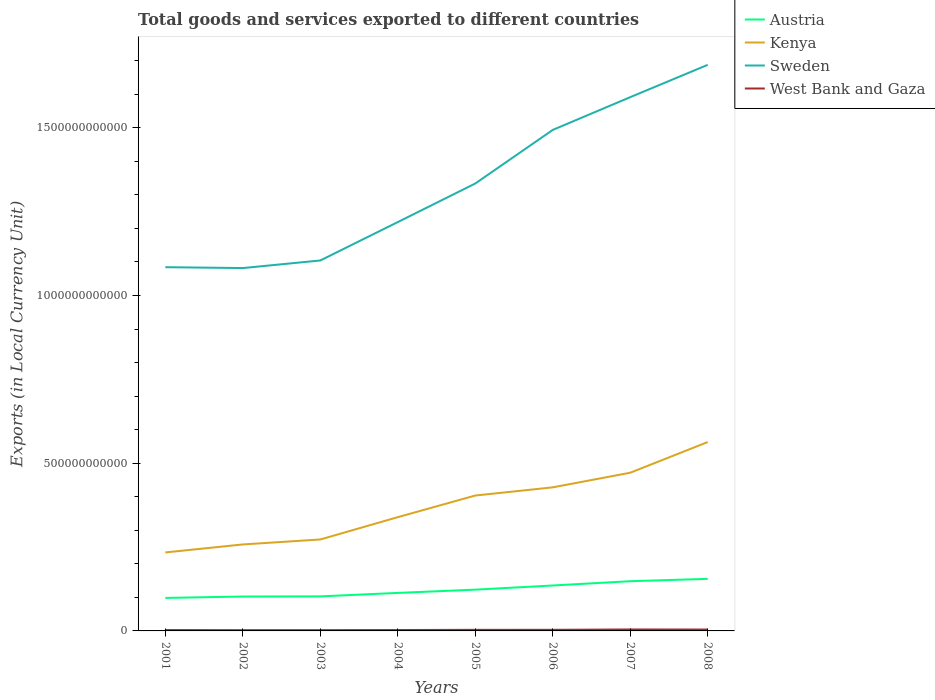How many different coloured lines are there?
Offer a terse response. 4. Does the line corresponding to West Bank and Gaza intersect with the line corresponding to Kenya?
Ensure brevity in your answer.  No. Is the number of lines equal to the number of legend labels?
Keep it short and to the point. Yes. Across all years, what is the maximum Amount of goods and services exports in Austria?
Your answer should be compact. 9.84e+1. What is the total Amount of goods and services exports in West Bank and Gaza in the graph?
Your answer should be very brief. -8.07e+07. What is the difference between the highest and the second highest Amount of goods and services exports in West Bank and Gaza?
Provide a short and direct response. 2.12e+09. Is the Amount of goods and services exports in West Bank and Gaza strictly greater than the Amount of goods and services exports in Sweden over the years?
Keep it short and to the point. Yes. How many years are there in the graph?
Your response must be concise. 8. What is the difference between two consecutive major ticks on the Y-axis?
Your answer should be compact. 5.00e+11. Are the values on the major ticks of Y-axis written in scientific E-notation?
Provide a short and direct response. No. Does the graph contain grids?
Your answer should be compact. No. Where does the legend appear in the graph?
Make the answer very short. Top right. How many legend labels are there?
Provide a succinct answer. 4. What is the title of the graph?
Give a very brief answer. Total goods and services exported to different countries. What is the label or title of the Y-axis?
Ensure brevity in your answer.  Exports (in Local Currency Unit). What is the Exports (in Local Currency Unit) in Austria in 2001?
Provide a succinct answer. 9.84e+1. What is the Exports (in Local Currency Unit) in Kenya in 2001?
Provide a succinct answer. 2.34e+11. What is the Exports (in Local Currency Unit) in Sweden in 2001?
Your response must be concise. 1.08e+12. What is the Exports (in Local Currency Unit) in West Bank and Gaza in 2001?
Give a very brief answer. 2.59e+09. What is the Exports (in Local Currency Unit) in Austria in 2002?
Give a very brief answer. 1.03e+11. What is the Exports (in Local Currency Unit) in Kenya in 2002?
Give a very brief answer. 2.58e+11. What is the Exports (in Local Currency Unit) in Sweden in 2002?
Offer a very short reply. 1.08e+12. What is the Exports (in Local Currency Unit) in West Bank and Gaza in 2002?
Keep it short and to the point. 2.26e+09. What is the Exports (in Local Currency Unit) of Austria in 2003?
Give a very brief answer. 1.03e+11. What is the Exports (in Local Currency Unit) in Kenya in 2003?
Give a very brief answer. 2.73e+11. What is the Exports (in Local Currency Unit) of Sweden in 2003?
Provide a short and direct response. 1.10e+12. What is the Exports (in Local Currency Unit) of West Bank and Gaza in 2003?
Your answer should be very brief. 2.34e+09. What is the Exports (in Local Currency Unit) of Austria in 2004?
Ensure brevity in your answer.  1.13e+11. What is the Exports (in Local Currency Unit) of Kenya in 2004?
Offer a terse response. 3.39e+11. What is the Exports (in Local Currency Unit) of Sweden in 2004?
Your answer should be very brief. 1.22e+12. What is the Exports (in Local Currency Unit) in West Bank and Gaza in 2004?
Make the answer very short. 2.67e+09. What is the Exports (in Local Currency Unit) in Austria in 2005?
Offer a terse response. 1.23e+11. What is the Exports (in Local Currency Unit) of Kenya in 2005?
Your response must be concise. 4.04e+11. What is the Exports (in Local Currency Unit) of Sweden in 2005?
Give a very brief answer. 1.33e+12. What is the Exports (in Local Currency Unit) in West Bank and Gaza in 2005?
Your response must be concise. 3.25e+09. What is the Exports (in Local Currency Unit) in Austria in 2006?
Make the answer very short. 1.35e+11. What is the Exports (in Local Currency Unit) of Kenya in 2006?
Your response must be concise. 4.28e+11. What is the Exports (in Local Currency Unit) in Sweden in 2006?
Provide a succinct answer. 1.49e+12. What is the Exports (in Local Currency Unit) in West Bank and Gaza in 2006?
Keep it short and to the point. 3.28e+09. What is the Exports (in Local Currency Unit) in Austria in 2007?
Offer a terse response. 1.48e+11. What is the Exports (in Local Currency Unit) of Kenya in 2007?
Offer a very short reply. 4.72e+11. What is the Exports (in Local Currency Unit) of Sweden in 2007?
Your answer should be very brief. 1.59e+12. What is the Exports (in Local Currency Unit) of West Bank and Gaza in 2007?
Offer a terse response. 4.38e+09. What is the Exports (in Local Currency Unit) of Austria in 2008?
Provide a short and direct response. 1.55e+11. What is the Exports (in Local Currency Unit) of Kenya in 2008?
Keep it short and to the point. 5.63e+11. What is the Exports (in Local Currency Unit) in Sweden in 2008?
Provide a short and direct response. 1.69e+12. What is the Exports (in Local Currency Unit) of West Bank and Gaza in 2008?
Provide a succinct answer. 4.12e+09. Across all years, what is the maximum Exports (in Local Currency Unit) in Austria?
Offer a terse response. 1.55e+11. Across all years, what is the maximum Exports (in Local Currency Unit) in Kenya?
Your answer should be compact. 5.63e+11. Across all years, what is the maximum Exports (in Local Currency Unit) of Sweden?
Offer a very short reply. 1.69e+12. Across all years, what is the maximum Exports (in Local Currency Unit) of West Bank and Gaza?
Offer a terse response. 4.38e+09. Across all years, what is the minimum Exports (in Local Currency Unit) of Austria?
Provide a short and direct response. 9.84e+1. Across all years, what is the minimum Exports (in Local Currency Unit) in Kenya?
Make the answer very short. 2.34e+11. Across all years, what is the minimum Exports (in Local Currency Unit) in Sweden?
Your answer should be very brief. 1.08e+12. Across all years, what is the minimum Exports (in Local Currency Unit) in West Bank and Gaza?
Ensure brevity in your answer.  2.26e+09. What is the total Exports (in Local Currency Unit) of Austria in the graph?
Make the answer very short. 9.79e+11. What is the total Exports (in Local Currency Unit) in Kenya in the graph?
Your response must be concise. 2.97e+12. What is the total Exports (in Local Currency Unit) in Sweden in the graph?
Ensure brevity in your answer.  1.06e+13. What is the total Exports (in Local Currency Unit) in West Bank and Gaza in the graph?
Keep it short and to the point. 2.49e+1. What is the difference between the Exports (in Local Currency Unit) in Austria in 2001 and that in 2002?
Your answer should be compact. -4.17e+09. What is the difference between the Exports (in Local Currency Unit) of Kenya in 2001 and that in 2002?
Give a very brief answer. -2.38e+1. What is the difference between the Exports (in Local Currency Unit) of Sweden in 2001 and that in 2002?
Your answer should be compact. 2.62e+09. What is the difference between the Exports (in Local Currency Unit) of West Bank and Gaza in 2001 and that in 2002?
Provide a succinct answer. 3.28e+08. What is the difference between the Exports (in Local Currency Unit) of Austria in 2001 and that in 2003?
Offer a very short reply. -4.61e+09. What is the difference between the Exports (in Local Currency Unit) in Kenya in 2001 and that in 2003?
Keep it short and to the point. -3.87e+1. What is the difference between the Exports (in Local Currency Unit) in Sweden in 2001 and that in 2003?
Give a very brief answer. -2.00e+1. What is the difference between the Exports (in Local Currency Unit) in West Bank and Gaza in 2001 and that in 2003?
Give a very brief answer. 2.54e+08. What is the difference between the Exports (in Local Currency Unit) of Austria in 2001 and that in 2004?
Your response must be concise. -1.49e+1. What is the difference between the Exports (in Local Currency Unit) in Kenya in 2001 and that in 2004?
Provide a short and direct response. -1.05e+11. What is the difference between the Exports (in Local Currency Unit) in Sweden in 2001 and that in 2004?
Your answer should be very brief. -1.34e+11. What is the difference between the Exports (in Local Currency Unit) in West Bank and Gaza in 2001 and that in 2004?
Your answer should be compact. -8.07e+07. What is the difference between the Exports (in Local Currency Unit) of Austria in 2001 and that in 2005?
Provide a succinct answer. -2.47e+1. What is the difference between the Exports (in Local Currency Unit) of Kenya in 2001 and that in 2005?
Your answer should be compact. -1.70e+11. What is the difference between the Exports (in Local Currency Unit) of Sweden in 2001 and that in 2005?
Make the answer very short. -2.49e+11. What is the difference between the Exports (in Local Currency Unit) in West Bank and Gaza in 2001 and that in 2005?
Keep it short and to the point. -6.55e+08. What is the difference between the Exports (in Local Currency Unit) of Austria in 2001 and that in 2006?
Your response must be concise. -3.71e+1. What is the difference between the Exports (in Local Currency Unit) of Kenya in 2001 and that in 2006?
Keep it short and to the point. -1.94e+11. What is the difference between the Exports (in Local Currency Unit) of Sweden in 2001 and that in 2006?
Offer a terse response. -4.09e+11. What is the difference between the Exports (in Local Currency Unit) in West Bank and Gaza in 2001 and that in 2006?
Your answer should be compact. -6.91e+08. What is the difference between the Exports (in Local Currency Unit) of Austria in 2001 and that in 2007?
Offer a terse response. -4.98e+1. What is the difference between the Exports (in Local Currency Unit) of Kenya in 2001 and that in 2007?
Your response must be concise. -2.38e+11. What is the difference between the Exports (in Local Currency Unit) in Sweden in 2001 and that in 2007?
Offer a very short reply. -5.07e+11. What is the difference between the Exports (in Local Currency Unit) in West Bank and Gaza in 2001 and that in 2007?
Offer a very short reply. -1.79e+09. What is the difference between the Exports (in Local Currency Unit) of Austria in 2001 and that in 2008?
Your answer should be very brief. -5.68e+1. What is the difference between the Exports (in Local Currency Unit) in Kenya in 2001 and that in 2008?
Your response must be concise. -3.29e+11. What is the difference between the Exports (in Local Currency Unit) of Sweden in 2001 and that in 2008?
Provide a short and direct response. -6.03e+11. What is the difference between the Exports (in Local Currency Unit) of West Bank and Gaza in 2001 and that in 2008?
Offer a very short reply. -1.53e+09. What is the difference between the Exports (in Local Currency Unit) in Austria in 2002 and that in 2003?
Your response must be concise. -4.44e+08. What is the difference between the Exports (in Local Currency Unit) in Kenya in 2002 and that in 2003?
Make the answer very short. -1.48e+1. What is the difference between the Exports (in Local Currency Unit) of Sweden in 2002 and that in 2003?
Your answer should be very brief. -2.26e+1. What is the difference between the Exports (in Local Currency Unit) of West Bank and Gaza in 2002 and that in 2003?
Ensure brevity in your answer.  -7.38e+07. What is the difference between the Exports (in Local Currency Unit) of Austria in 2002 and that in 2004?
Ensure brevity in your answer.  -1.08e+1. What is the difference between the Exports (in Local Currency Unit) of Kenya in 2002 and that in 2004?
Your answer should be compact. -8.13e+1. What is the difference between the Exports (in Local Currency Unit) in Sweden in 2002 and that in 2004?
Ensure brevity in your answer.  -1.37e+11. What is the difference between the Exports (in Local Currency Unit) in West Bank and Gaza in 2002 and that in 2004?
Your answer should be very brief. -4.09e+08. What is the difference between the Exports (in Local Currency Unit) in Austria in 2002 and that in 2005?
Offer a terse response. -2.05e+1. What is the difference between the Exports (in Local Currency Unit) of Kenya in 2002 and that in 2005?
Provide a succinct answer. -1.46e+11. What is the difference between the Exports (in Local Currency Unit) in Sweden in 2002 and that in 2005?
Make the answer very short. -2.52e+11. What is the difference between the Exports (in Local Currency Unit) in West Bank and Gaza in 2002 and that in 2005?
Ensure brevity in your answer.  -9.83e+08. What is the difference between the Exports (in Local Currency Unit) in Austria in 2002 and that in 2006?
Your answer should be compact. -3.29e+1. What is the difference between the Exports (in Local Currency Unit) in Kenya in 2002 and that in 2006?
Your answer should be very brief. -1.70e+11. What is the difference between the Exports (in Local Currency Unit) of Sweden in 2002 and that in 2006?
Your answer should be compact. -4.12e+11. What is the difference between the Exports (in Local Currency Unit) in West Bank and Gaza in 2002 and that in 2006?
Your answer should be compact. -1.02e+09. What is the difference between the Exports (in Local Currency Unit) of Austria in 2002 and that in 2007?
Offer a very short reply. -4.57e+1. What is the difference between the Exports (in Local Currency Unit) in Kenya in 2002 and that in 2007?
Give a very brief answer. -2.14e+11. What is the difference between the Exports (in Local Currency Unit) of Sweden in 2002 and that in 2007?
Give a very brief answer. -5.09e+11. What is the difference between the Exports (in Local Currency Unit) in West Bank and Gaza in 2002 and that in 2007?
Provide a short and direct response. -2.12e+09. What is the difference between the Exports (in Local Currency Unit) in Austria in 2002 and that in 2008?
Your answer should be very brief. -5.26e+1. What is the difference between the Exports (in Local Currency Unit) of Kenya in 2002 and that in 2008?
Your answer should be very brief. -3.05e+11. What is the difference between the Exports (in Local Currency Unit) of Sweden in 2002 and that in 2008?
Keep it short and to the point. -6.06e+11. What is the difference between the Exports (in Local Currency Unit) of West Bank and Gaza in 2002 and that in 2008?
Your answer should be very brief. -1.86e+09. What is the difference between the Exports (in Local Currency Unit) in Austria in 2003 and that in 2004?
Your answer should be compact. -1.03e+1. What is the difference between the Exports (in Local Currency Unit) of Kenya in 2003 and that in 2004?
Provide a short and direct response. -6.65e+1. What is the difference between the Exports (in Local Currency Unit) in Sweden in 2003 and that in 2004?
Provide a succinct answer. -1.14e+11. What is the difference between the Exports (in Local Currency Unit) in West Bank and Gaza in 2003 and that in 2004?
Give a very brief answer. -3.35e+08. What is the difference between the Exports (in Local Currency Unit) of Austria in 2003 and that in 2005?
Make the answer very short. -2.01e+1. What is the difference between the Exports (in Local Currency Unit) in Kenya in 2003 and that in 2005?
Make the answer very short. -1.31e+11. What is the difference between the Exports (in Local Currency Unit) in Sweden in 2003 and that in 2005?
Your answer should be very brief. -2.29e+11. What is the difference between the Exports (in Local Currency Unit) in West Bank and Gaza in 2003 and that in 2005?
Your answer should be very brief. -9.09e+08. What is the difference between the Exports (in Local Currency Unit) in Austria in 2003 and that in 2006?
Make the answer very short. -3.25e+1. What is the difference between the Exports (in Local Currency Unit) in Kenya in 2003 and that in 2006?
Keep it short and to the point. -1.55e+11. What is the difference between the Exports (in Local Currency Unit) of Sweden in 2003 and that in 2006?
Keep it short and to the point. -3.89e+11. What is the difference between the Exports (in Local Currency Unit) of West Bank and Gaza in 2003 and that in 2006?
Provide a short and direct response. -9.45e+08. What is the difference between the Exports (in Local Currency Unit) in Austria in 2003 and that in 2007?
Offer a very short reply. -4.52e+1. What is the difference between the Exports (in Local Currency Unit) in Kenya in 2003 and that in 2007?
Provide a short and direct response. -1.99e+11. What is the difference between the Exports (in Local Currency Unit) of Sweden in 2003 and that in 2007?
Offer a very short reply. -4.87e+11. What is the difference between the Exports (in Local Currency Unit) in West Bank and Gaza in 2003 and that in 2007?
Your response must be concise. -2.04e+09. What is the difference between the Exports (in Local Currency Unit) in Austria in 2003 and that in 2008?
Provide a succinct answer. -5.22e+1. What is the difference between the Exports (in Local Currency Unit) in Kenya in 2003 and that in 2008?
Offer a terse response. -2.90e+11. What is the difference between the Exports (in Local Currency Unit) in Sweden in 2003 and that in 2008?
Give a very brief answer. -5.83e+11. What is the difference between the Exports (in Local Currency Unit) in West Bank and Gaza in 2003 and that in 2008?
Your answer should be very brief. -1.79e+09. What is the difference between the Exports (in Local Currency Unit) of Austria in 2004 and that in 2005?
Your response must be concise. -9.74e+09. What is the difference between the Exports (in Local Currency Unit) of Kenya in 2004 and that in 2005?
Your answer should be compact. -6.45e+1. What is the difference between the Exports (in Local Currency Unit) of Sweden in 2004 and that in 2005?
Make the answer very short. -1.15e+11. What is the difference between the Exports (in Local Currency Unit) of West Bank and Gaza in 2004 and that in 2005?
Your response must be concise. -5.74e+08. What is the difference between the Exports (in Local Currency Unit) of Austria in 2004 and that in 2006?
Make the answer very short. -2.21e+1. What is the difference between the Exports (in Local Currency Unit) of Kenya in 2004 and that in 2006?
Make the answer very short. -8.89e+1. What is the difference between the Exports (in Local Currency Unit) of Sweden in 2004 and that in 2006?
Your answer should be compact. -2.75e+11. What is the difference between the Exports (in Local Currency Unit) in West Bank and Gaza in 2004 and that in 2006?
Provide a succinct answer. -6.10e+08. What is the difference between the Exports (in Local Currency Unit) of Austria in 2004 and that in 2007?
Keep it short and to the point. -3.49e+1. What is the difference between the Exports (in Local Currency Unit) in Kenya in 2004 and that in 2007?
Provide a short and direct response. -1.32e+11. What is the difference between the Exports (in Local Currency Unit) in Sweden in 2004 and that in 2007?
Provide a short and direct response. -3.72e+11. What is the difference between the Exports (in Local Currency Unit) in West Bank and Gaza in 2004 and that in 2007?
Your answer should be very brief. -1.71e+09. What is the difference between the Exports (in Local Currency Unit) in Austria in 2004 and that in 2008?
Give a very brief answer. -4.19e+1. What is the difference between the Exports (in Local Currency Unit) of Kenya in 2004 and that in 2008?
Make the answer very short. -2.24e+11. What is the difference between the Exports (in Local Currency Unit) in Sweden in 2004 and that in 2008?
Make the answer very short. -4.69e+11. What is the difference between the Exports (in Local Currency Unit) in West Bank and Gaza in 2004 and that in 2008?
Make the answer very short. -1.45e+09. What is the difference between the Exports (in Local Currency Unit) in Austria in 2005 and that in 2006?
Your response must be concise. -1.24e+1. What is the difference between the Exports (in Local Currency Unit) in Kenya in 2005 and that in 2006?
Offer a terse response. -2.44e+1. What is the difference between the Exports (in Local Currency Unit) of Sweden in 2005 and that in 2006?
Give a very brief answer. -1.60e+11. What is the difference between the Exports (in Local Currency Unit) in West Bank and Gaza in 2005 and that in 2006?
Your response must be concise. -3.63e+07. What is the difference between the Exports (in Local Currency Unit) of Austria in 2005 and that in 2007?
Your answer should be very brief. -2.51e+1. What is the difference between the Exports (in Local Currency Unit) in Kenya in 2005 and that in 2007?
Keep it short and to the point. -6.79e+1. What is the difference between the Exports (in Local Currency Unit) in Sweden in 2005 and that in 2007?
Make the answer very short. -2.57e+11. What is the difference between the Exports (in Local Currency Unit) of West Bank and Gaza in 2005 and that in 2007?
Your answer should be very brief. -1.13e+09. What is the difference between the Exports (in Local Currency Unit) in Austria in 2005 and that in 2008?
Your answer should be compact. -3.21e+1. What is the difference between the Exports (in Local Currency Unit) in Kenya in 2005 and that in 2008?
Ensure brevity in your answer.  -1.59e+11. What is the difference between the Exports (in Local Currency Unit) of Sweden in 2005 and that in 2008?
Provide a succinct answer. -3.54e+11. What is the difference between the Exports (in Local Currency Unit) of West Bank and Gaza in 2005 and that in 2008?
Offer a terse response. -8.76e+08. What is the difference between the Exports (in Local Currency Unit) of Austria in 2006 and that in 2007?
Your answer should be very brief. -1.27e+1. What is the difference between the Exports (in Local Currency Unit) of Kenya in 2006 and that in 2007?
Your response must be concise. -4.36e+1. What is the difference between the Exports (in Local Currency Unit) in Sweden in 2006 and that in 2007?
Your answer should be compact. -9.76e+1. What is the difference between the Exports (in Local Currency Unit) of West Bank and Gaza in 2006 and that in 2007?
Your answer should be very brief. -1.10e+09. What is the difference between the Exports (in Local Currency Unit) in Austria in 2006 and that in 2008?
Keep it short and to the point. -1.97e+1. What is the difference between the Exports (in Local Currency Unit) in Kenya in 2006 and that in 2008?
Ensure brevity in your answer.  -1.35e+11. What is the difference between the Exports (in Local Currency Unit) in Sweden in 2006 and that in 2008?
Your response must be concise. -1.94e+11. What is the difference between the Exports (in Local Currency Unit) in West Bank and Gaza in 2006 and that in 2008?
Provide a succinct answer. -8.40e+08. What is the difference between the Exports (in Local Currency Unit) of Austria in 2007 and that in 2008?
Your answer should be very brief. -6.99e+09. What is the difference between the Exports (in Local Currency Unit) in Kenya in 2007 and that in 2008?
Your answer should be compact. -9.15e+1. What is the difference between the Exports (in Local Currency Unit) of Sweden in 2007 and that in 2008?
Give a very brief answer. -9.64e+1. What is the difference between the Exports (in Local Currency Unit) of West Bank and Gaza in 2007 and that in 2008?
Your response must be concise. 2.58e+08. What is the difference between the Exports (in Local Currency Unit) of Austria in 2001 and the Exports (in Local Currency Unit) of Kenya in 2002?
Keep it short and to the point. -1.59e+11. What is the difference between the Exports (in Local Currency Unit) of Austria in 2001 and the Exports (in Local Currency Unit) of Sweden in 2002?
Give a very brief answer. -9.83e+11. What is the difference between the Exports (in Local Currency Unit) in Austria in 2001 and the Exports (in Local Currency Unit) in West Bank and Gaza in 2002?
Your answer should be compact. 9.61e+1. What is the difference between the Exports (in Local Currency Unit) of Kenya in 2001 and the Exports (in Local Currency Unit) of Sweden in 2002?
Offer a terse response. -8.48e+11. What is the difference between the Exports (in Local Currency Unit) in Kenya in 2001 and the Exports (in Local Currency Unit) in West Bank and Gaza in 2002?
Offer a terse response. 2.32e+11. What is the difference between the Exports (in Local Currency Unit) in Sweden in 2001 and the Exports (in Local Currency Unit) in West Bank and Gaza in 2002?
Your response must be concise. 1.08e+12. What is the difference between the Exports (in Local Currency Unit) of Austria in 2001 and the Exports (in Local Currency Unit) of Kenya in 2003?
Your answer should be very brief. -1.74e+11. What is the difference between the Exports (in Local Currency Unit) in Austria in 2001 and the Exports (in Local Currency Unit) in Sweden in 2003?
Give a very brief answer. -1.01e+12. What is the difference between the Exports (in Local Currency Unit) in Austria in 2001 and the Exports (in Local Currency Unit) in West Bank and Gaza in 2003?
Your answer should be compact. 9.60e+1. What is the difference between the Exports (in Local Currency Unit) of Kenya in 2001 and the Exports (in Local Currency Unit) of Sweden in 2003?
Your answer should be very brief. -8.70e+11. What is the difference between the Exports (in Local Currency Unit) of Kenya in 2001 and the Exports (in Local Currency Unit) of West Bank and Gaza in 2003?
Keep it short and to the point. 2.32e+11. What is the difference between the Exports (in Local Currency Unit) in Sweden in 2001 and the Exports (in Local Currency Unit) in West Bank and Gaza in 2003?
Ensure brevity in your answer.  1.08e+12. What is the difference between the Exports (in Local Currency Unit) in Austria in 2001 and the Exports (in Local Currency Unit) in Kenya in 2004?
Your answer should be compact. -2.41e+11. What is the difference between the Exports (in Local Currency Unit) of Austria in 2001 and the Exports (in Local Currency Unit) of Sweden in 2004?
Keep it short and to the point. -1.12e+12. What is the difference between the Exports (in Local Currency Unit) of Austria in 2001 and the Exports (in Local Currency Unit) of West Bank and Gaza in 2004?
Make the answer very short. 9.57e+1. What is the difference between the Exports (in Local Currency Unit) of Kenya in 2001 and the Exports (in Local Currency Unit) of Sweden in 2004?
Ensure brevity in your answer.  -9.85e+11. What is the difference between the Exports (in Local Currency Unit) in Kenya in 2001 and the Exports (in Local Currency Unit) in West Bank and Gaza in 2004?
Your response must be concise. 2.31e+11. What is the difference between the Exports (in Local Currency Unit) of Sweden in 2001 and the Exports (in Local Currency Unit) of West Bank and Gaza in 2004?
Keep it short and to the point. 1.08e+12. What is the difference between the Exports (in Local Currency Unit) of Austria in 2001 and the Exports (in Local Currency Unit) of Kenya in 2005?
Ensure brevity in your answer.  -3.05e+11. What is the difference between the Exports (in Local Currency Unit) in Austria in 2001 and the Exports (in Local Currency Unit) in Sweden in 2005?
Ensure brevity in your answer.  -1.24e+12. What is the difference between the Exports (in Local Currency Unit) in Austria in 2001 and the Exports (in Local Currency Unit) in West Bank and Gaza in 2005?
Keep it short and to the point. 9.51e+1. What is the difference between the Exports (in Local Currency Unit) of Kenya in 2001 and the Exports (in Local Currency Unit) of Sweden in 2005?
Offer a very short reply. -1.10e+12. What is the difference between the Exports (in Local Currency Unit) in Kenya in 2001 and the Exports (in Local Currency Unit) in West Bank and Gaza in 2005?
Keep it short and to the point. 2.31e+11. What is the difference between the Exports (in Local Currency Unit) of Sweden in 2001 and the Exports (in Local Currency Unit) of West Bank and Gaza in 2005?
Provide a short and direct response. 1.08e+12. What is the difference between the Exports (in Local Currency Unit) in Austria in 2001 and the Exports (in Local Currency Unit) in Kenya in 2006?
Give a very brief answer. -3.30e+11. What is the difference between the Exports (in Local Currency Unit) of Austria in 2001 and the Exports (in Local Currency Unit) of Sweden in 2006?
Your answer should be very brief. -1.40e+12. What is the difference between the Exports (in Local Currency Unit) of Austria in 2001 and the Exports (in Local Currency Unit) of West Bank and Gaza in 2006?
Make the answer very short. 9.51e+1. What is the difference between the Exports (in Local Currency Unit) in Kenya in 2001 and the Exports (in Local Currency Unit) in Sweden in 2006?
Make the answer very short. -1.26e+12. What is the difference between the Exports (in Local Currency Unit) in Kenya in 2001 and the Exports (in Local Currency Unit) in West Bank and Gaza in 2006?
Your answer should be compact. 2.31e+11. What is the difference between the Exports (in Local Currency Unit) in Sweden in 2001 and the Exports (in Local Currency Unit) in West Bank and Gaza in 2006?
Offer a very short reply. 1.08e+12. What is the difference between the Exports (in Local Currency Unit) in Austria in 2001 and the Exports (in Local Currency Unit) in Kenya in 2007?
Make the answer very short. -3.73e+11. What is the difference between the Exports (in Local Currency Unit) in Austria in 2001 and the Exports (in Local Currency Unit) in Sweden in 2007?
Offer a terse response. -1.49e+12. What is the difference between the Exports (in Local Currency Unit) of Austria in 2001 and the Exports (in Local Currency Unit) of West Bank and Gaza in 2007?
Provide a short and direct response. 9.40e+1. What is the difference between the Exports (in Local Currency Unit) in Kenya in 2001 and the Exports (in Local Currency Unit) in Sweden in 2007?
Your answer should be compact. -1.36e+12. What is the difference between the Exports (in Local Currency Unit) in Kenya in 2001 and the Exports (in Local Currency Unit) in West Bank and Gaza in 2007?
Give a very brief answer. 2.30e+11. What is the difference between the Exports (in Local Currency Unit) in Sweden in 2001 and the Exports (in Local Currency Unit) in West Bank and Gaza in 2007?
Offer a very short reply. 1.08e+12. What is the difference between the Exports (in Local Currency Unit) of Austria in 2001 and the Exports (in Local Currency Unit) of Kenya in 2008?
Offer a very short reply. -4.65e+11. What is the difference between the Exports (in Local Currency Unit) of Austria in 2001 and the Exports (in Local Currency Unit) of Sweden in 2008?
Your answer should be very brief. -1.59e+12. What is the difference between the Exports (in Local Currency Unit) of Austria in 2001 and the Exports (in Local Currency Unit) of West Bank and Gaza in 2008?
Make the answer very short. 9.42e+1. What is the difference between the Exports (in Local Currency Unit) in Kenya in 2001 and the Exports (in Local Currency Unit) in Sweden in 2008?
Your answer should be very brief. -1.45e+12. What is the difference between the Exports (in Local Currency Unit) in Kenya in 2001 and the Exports (in Local Currency Unit) in West Bank and Gaza in 2008?
Ensure brevity in your answer.  2.30e+11. What is the difference between the Exports (in Local Currency Unit) of Sweden in 2001 and the Exports (in Local Currency Unit) of West Bank and Gaza in 2008?
Provide a short and direct response. 1.08e+12. What is the difference between the Exports (in Local Currency Unit) of Austria in 2002 and the Exports (in Local Currency Unit) of Kenya in 2003?
Offer a very short reply. -1.70e+11. What is the difference between the Exports (in Local Currency Unit) of Austria in 2002 and the Exports (in Local Currency Unit) of Sweden in 2003?
Ensure brevity in your answer.  -1.00e+12. What is the difference between the Exports (in Local Currency Unit) of Austria in 2002 and the Exports (in Local Currency Unit) of West Bank and Gaza in 2003?
Your response must be concise. 1.00e+11. What is the difference between the Exports (in Local Currency Unit) in Kenya in 2002 and the Exports (in Local Currency Unit) in Sweden in 2003?
Make the answer very short. -8.47e+11. What is the difference between the Exports (in Local Currency Unit) of Kenya in 2002 and the Exports (in Local Currency Unit) of West Bank and Gaza in 2003?
Offer a terse response. 2.55e+11. What is the difference between the Exports (in Local Currency Unit) in Sweden in 2002 and the Exports (in Local Currency Unit) in West Bank and Gaza in 2003?
Provide a short and direct response. 1.08e+12. What is the difference between the Exports (in Local Currency Unit) of Austria in 2002 and the Exports (in Local Currency Unit) of Kenya in 2004?
Offer a terse response. -2.37e+11. What is the difference between the Exports (in Local Currency Unit) of Austria in 2002 and the Exports (in Local Currency Unit) of Sweden in 2004?
Provide a short and direct response. -1.12e+12. What is the difference between the Exports (in Local Currency Unit) in Austria in 2002 and the Exports (in Local Currency Unit) in West Bank and Gaza in 2004?
Provide a succinct answer. 9.99e+1. What is the difference between the Exports (in Local Currency Unit) of Kenya in 2002 and the Exports (in Local Currency Unit) of Sweden in 2004?
Your answer should be very brief. -9.61e+11. What is the difference between the Exports (in Local Currency Unit) of Kenya in 2002 and the Exports (in Local Currency Unit) of West Bank and Gaza in 2004?
Make the answer very short. 2.55e+11. What is the difference between the Exports (in Local Currency Unit) of Sweden in 2002 and the Exports (in Local Currency Unit) of West Bank and Gaza in 2004?
Ensure brevity in your answer.  1.08e+12. What is the difference between the Exports (in Local Currency Unit) of Austria in 2002 and the Exports (in Local Currency Unit) of Kenya in 2005?
Your response must be concise. -3.01e+11. What is the difference between the Exports (in Local Currency Unit) of Austria in 2002 and the Exports (in Local Currency Unit) of Sweden in 2005?
Your answer should be very brief. -1.23e+12. What is the difference between the Exports (in Local Currency Unit) of Austria in 2002 and the Exports (in Local Currency Unit) of West Bank and Gaza in 2005?
Your answer should be compact. 9.93e+1. What is the difference between the Exports (in Local Currency Unit) in Kenya in 2002 and the Exports (in Local Currency Unit) in Sweden in 2005?
Keep it short and to the point. -1.08e+12. What is the difference between the Exports (in Local Currency Unit) in Kenya in 2002 and the Exports (in Local Currency Unit) in West Bank and Gaza in 2005?
Your answer should be very brief. 2.55e+11. What is the difference between the Exports (in Local Currency Unit) in Sweden in 2002 and the Exports (in Local Currency Unit) in West Bank and Gaza in 2005?
Make the answer very short. 1.08e+12. What is the difference between the Exports (in Local Currency Unit) in Austria in 2002 and the Exports (in Local Currency Unit) in Kenya in 2006?
Offer a terse response. -3.25e+11. What is the difference between the Exports (in Local Currency Unit) of Austria in 2002 and the Exports (in Local Currency Unit) of Sweden in 2006?
Your response must be concise. -1.39e+12. What is the difference between the Exports (in Local Currency Unit) in Austria in 2002 and the Exports (in Local Currency Unit) in West Bank and Gaza in 2006?
Give a very brief answer. 9.93e+1. What is the difference between the Exports (in Local Currency Unit) in Kenya in 2002 and the Exports (in Local Currency Unit) in Sweden in 2006?
Ensure brevity in your answer.  -1.24e+12. What is the difference between the Exports (in Local Currency Unit) of Kenya in 2002 and the Exports (in Local Currency Unit) of West Bank and Gaza in 2006?
Your response must be concise. 2.55e+11. What is the difference between the Exports (in Local Currency Unit) in Sweden in 2002 and the Exports (in Local Currency Unit) in West Bank and Gaza in 2006?
Keep it short and to the point. 1.08e+12. What is the difference between the Exports (in Local Currency Unit) in Austria in 2002 and the Exports (in Local Currency Unit) in Kenya in 2007?
Give a very brief answer. -3.69e+11. What is the difference between the Exports (in Local Currency Unit) in Austria in 2002 and the Exports (in Local Currency Unit) in Sweden in 2007?
Provide a succinct answer. -1.49e+12. What is the difference between the Exports (in Local Currency Unit) in Austria in 2002 and the Exports (in Local Currency Unit) in West Bank and Gaza in 2007?
Your answer should be very brief. 9.82e+1. What is the difference between the Exports (in Local Currency Unit) of Kenya in 2002 and the Exports (in Local Currency Unit) of Sweden in 2007?
Provide a succinct answer. -1.33e+12. What is the difference between the Exports (in Local Currency Unit) of Kenya in 2002 and the Exports (in Local Currency Unit) of West Bank and Gaza in 2007?
Your response must be concise. 2.53e+11. What is the difference between the Exports (in Local Currency Unit) of Sweden in 2002 and the Exports (in Local Currency Unit) of West Bank and Gaza in 2007?
Make the answer very short. 1.08e+12. What is the difference between the Exports (in Local Currency Unit) of Austria in 2002 and the Exports (in Local Currency Unit) of Kenya in 2008?
Keep it short and to the point. -4.60e+11. What is the difference between the Exports (in Local Currency Unit) in Austria in 2002 and the Exports (in Local Currency Unit) in Sweden in 2008?
Ensure brevity in your answer.  -1.58e+12. What is the difference between the Exports (in Local Currency Unit) of Austria in 2002 and the Exports (in Local Currency Unit) of West Bank and Gaza in 2008?
Make the answer very short. 9.84e+1. What is the difference between the Exports (in Local Currency Unit) of Kenya in 2002 and the Exports (in Local Currency Unit) of Sweden in 2008?
Give a very brief answer. -1.43e+12. What is the difference between the Exports (in Local Currency Unit) of Kenya in 2002 and the Exports (in Local Currency Unit) of West Bank and Gaza in 2008?
Offer a very short reply. 2.54e+11. What is the difference between the Exports (in Local Currency Unit) of Sweden in 2002 and the Exports (in Local Currency Unit) of West Bank and Gaza in 2008?
Your response must be concise. 1.08e+12. What is the difference between the Exports (in Local Currency Unit) of Austria in 2003 and the Exports (in Local Currency Unit) of Kenya in 2004?
Provide a short and direct response. -2.36e+11. What is the difference between the Exports (in Local Currency Unit) in Austria in 2003 and the Exports (in Local Currency Unit) in Sweden in 2004?
Ensure brevity in your answer.  -1.12e+12. What is the difference between the Exports (in Local Currency Unit) of Austria in 2003 and the Exports (in Local Currency Unit) of West Bank and Gaza in 2004?
Provide a succinct answer. 1.00e+11. What is the difference between the Exports (in Local Currency Unit) in Kenya in 2003 and the Exports (in Local Currency Unit) in Sweden in 2004?
Provide a succinct answer. -9.46e+11. What is the difference between the Exports (in Local Currency Unit) of Kenya in 2003 and the Exports (in Local Currency Unit) of West Bank and Gaza in 2004?
Offer a terse response. 2.70e+11. What is the difference between the Exports (in Local Currency Unit) of Sweden in 2003 and the Exports (in Local Currency Unit) of West Bank and Gaza in 2004?
Give a very brief answer. 1.10e+12. What is the difference between the Exports (in Local Currency Unit) of Austria in 2003 and the Exports (in Local Currency Unit) of Kenya in 2005?
Make the answer very short. -3.01e+11. What is the difference between the Exports (in Local Currency Unit) of Austria in 2003 and the Exports (in Local Currency Unit) of Sweden in 2005?
Provide a succinct answer. -1.23e+12. What is the difference between the Exports (in Local Currency Unit) of Austria in 2003 and the Exports (in Local Currency Unit) of West Bank and Gaza in 2005?
Keep it short and to the point. 9.97e+1. What is the difference between the Exports (in Local Currency Unit) in Kenya in 2003 and the Exports (in Local Currency Unit) in Sweden in 2005?
Offer a terse response. -1.06e+12. What is the difference between the Exports (in Local Currency Unit) in Kenya in 2003 and the Exports (in Local Currency Unit) in West Bank and Gaza in 2005?
Offer a terse response. 2.69e+11. What is the difference between the Exports (in Local Currency Unit) of Sweden in 2003 and the Exports (in Local Currency Unit) of West Bank and Gaza in 2005?
Offer a very short reply. 1.10e+12. What is the difference between the Exports (in Local Currency Unit) of Austria in 2003 and the Exports (in Local Currency Unit) of Kenya in 2006?
Provide a succinct answer. -3.25e+11. What is the difference between the Exports (in Local Currency Unit) of Austria in 2003 and the Exports (in Local Currency Unit) of Sweden in 2006?
Provide a short and direct response. -1.39e+12. What is the difference between the Exports (in Local Currency Unit) in Austria in 2003 and the Exports (in Local Currency Unit) in West Bank and Gaza in 2006?
Provide a short and direct response. 9.97e+1. What is the difference between the Exports (in Local Currency Unit) in Kenya in 2003 and the Exports (in Local Currency Unit) in Sweden in 2006?
Your answer should be compact. -1.22e+12. What is the difference between the Exports (in Local Currency Unit) in Kenya in 2003 and the Exports (in Local Currency Unit) in West Bank and Gaza in 2006?
Your answer should be compact. 2.69e+11. What is the difference between the Exports (in Local Currency Unit) of Sweden in 2003 and the Exports (in Local Currency Unit) of West Bank and Gaza in 2006?
Keep it short and to the point. 1.10e+12. What is the difference between the Exports (in Local Currency Unit) in Austria in 2003 and the Exports (in Local Currency Unit) in Kenya in 2007?
Your response must be concise. -3.69e+11. What is the difference between the Exports (in Local Currency Unit) in Austria in 2003 and the Exports (in Local Currency Unit) in Sweden in 2007?
Offer a terse response. -1.49e+12. What is the difference between the Exports (in Local Currency Unit) in Austria in 2003 and the Exports (in Local Currency Unit) in West Bank and Gaza in 2007?
Make the answer very short. 9.86e+1. What is the difference between the Exports (in Local Currency Unit) of Kenya in 2003 and the Exports (in Local Currency Unit) of Sweden in 2007?
Provide a succinct answer. -1.32e+12. What is the difference between the Exports (in Local Currency Unit) in Kenya in 2003 and the Exports (in Local Currency Unit) in West Bank and Gaza in 2007?
Offer a terse response. 2.68e+11. What is the difference between the Exports (in Local Currency Unit) in Sweden in 2003 and the Exports (in Local Currency Unit) in West Bank and Gaza in 2007?
Make the answer very short. 1.10e+12. What is the difference between the Exports (in Local Currency Unit) of Austria in 2003 and the Exports (in Local Currency Unit) of Kenya in 2008?
Keep it short and to the point. -4.60e+11. What is the difference between the Exports (in Local Currency Unit) in Austria in 2003 and the Exports (in Local Currency Unit) in Sweden in 2008?
Provide a succinct answer. -1.58e+12. What is the difference between the Exports (in Local Currency Unit) in Austria in 2003 and the Exports (in Local Currency Unit) in West Bank and Gaza in 2008?
Your response must be concise. 9.89e+1. What is the difference between the Exports (in Local Currency Unit) in Kenya in 2003 and the Exports (in Local Currency Unit) in Sweden in 2008?
Keep it short and to the point. -1.41e+12. What is the difference between the Exports (in Local Currency Unit) in Kenya in 2003 and the Exports (in Local Currency Unit) in West Bank and Gaza in 2008?
Make the answer very short. 2.68e+11. What is the difference between the Exports (in Local Currency Unit) in Sweden in 2003 and the Exports (in Local Currency Unit) in West Bank and Gaza in 2008?
Make the answer very short. 1.10e+12. What is the difference between the Exports (in Local Currency Unit) of Austria in 2004 and the Exports (in Local Currency Unit) of Kenya in 2005?
Your response must be concise. -2.90e+11. What is the difference between the Exports (in Local Currency Unit) of Austria in 2004 and the Exports (in Local Currency Unit) of Sweden in 2005?
Give a very brief answer. -1.22e+12. What is the difference between the Exports (in Local Currency Unit) of Austria in 2004 and the Exports (in Local Currency Unit) of West Bank and Gaza in 2005?
Your answer should be compact. 1.10e+11. What is the difference between the Exports (in Local Currency Unit) in Kenya in 2004 and the Exports (in Local Currency Unit) in Sweden in 2005?
Ensure brevity in your answer.  -9.95e+11. What is the difference between the Exports (in Local Currency Unit) in Kenya in 2004 and the Exports (in Local Currency Unit) in West Bank and Gaza in 2005?
Your response must be concise. 3.36e+11. What is the difference between the Exports (in Local Currency Unit) of Sweden in 2004 and the Exports (in Local Currency Unit) of West Bank and Gaza in 2005?
Ensure brevity in your answer.  1.22e+12. What is the difference between the Exports (in Local Currency Unit) of Austria in 2004 and the Exports (in Local Currency Unit) of Kenya in 2006?
Offer a very short reply. -3.15e+11. What is the difference between the Exports (in Local Currency Unit) in Austria in 2004 and the Exports (in Local Currency Unit) in Sweden in 2006?
Keep it short and to the point. -1.38e+12. What is the difference between the Exports (in Local Currency Unit) of Austria in 2004 and the Exports (in Local Currency Unit) of West Bank and Gaza in 2006?
Provide a succinct answer. 1.10e+11. What is the difference between the Exports (in Local Currency Unit) of Kenya in 2004 and the Exports (in Local Currency Unit) of Sweden in 2006?
Offer a terse response. -1.15e+12. What is the difference between the Exports (in Local Currency Unit) in Kenya in 2004 and the Exports (in Local Currency Unit) in West Bank and Gaza in 2006?
Your answer should be very brief. 3.36e+11. What is the difference between the Exports (in Local Currency Unit) in Sweden in 2004 and the Exports (in Local Currency Unit) in West Bank and Gaza in 2006?
Offer a very short reply. 1.22e+12. What is the difference between the Exports (in Local Currency Unit) in Austria in 2004 and the Exports (in Local Currency Unit) in Kenya in 2007?
Provide a short and direct response. -3.58e+11. What is the difference between the Exports (in Local Currency Unit) of Austria in 2004 and the Exports (in Local Currency Unit) of Sweden in 2007?
Your answer should be compact. -1.48e+12. What is the difference between the Exports (in Local Currency Unit) in Austria in 2004 and the Exports (in Local Currency Unit) in West Bank and Gaza in 2007?
Your answer should be compact. 1.09e+11. What is the difference between the Exports (in Local Currency Unit) of Kenya in 2004 and the Exports (in Local Currency Unit) of Sweden in 2007?
Your answer should be compact. -1.25e+12. What is the difference between the Exports (in Local Currency Unit) in Kenya in 2004 and the Exports (in Local Currency Unit) in West Bank and Gaza in 2007?
Offer a terse response. 3.35e+11. What is the difference between the Exports (in Local Currency Unit) of Sweden in 2004 and the Exports (in Local Currency Unit) of West Bank and Gaza in 2007?
Make the answer very short. 1.21e+12. What is the difference between the Exports (in Local Currency Unit) in Austria in 2004 and the Exports (in Local Currency Unit) in Kenya in 2008?
Make the answer very short. -4.50e+11. What is the difference between the Exports (in Local Currency Unit) of Austria in 2004 and the Exports (in Local Currency Unit) of Sweden in 2008?
Your answer should be very brief. -1.57e+12. What is the difference between the Exports (in Local Currency Unit) of Austria in 2004 and the Exports (in Local Currency Unit) of West Bank and Gaza in 2008?
Offer a terse response. 1.09e+11. What is the difference between the Exports (in Local Currency Unit) in Kenya in 2004 and the Exports (in Local Currency Unit) in Sweden in 2008?
Your response must be concise. -1.35e+12. What is the difference between the Exports (in Local Currency Unit) in Kenya in 2004 and the Exports (in Local Currency Unit) in West Bank and Gaza in 2008?
Your answer should be compact. 3.35e+11. What is the difference between the Exports (in Local Currency Unit) in Sweden in 2004 and the Exports (in Local Currency Unit) in West Bank and Gaza in 2008?
Your response must be concise. 1.21e+12. What is the difference between the Exports (in Local Currency Unit) of Austria in 2005 and the Exports (in Local Currency Unit) of Kenya in 2006?
Offer a terse response. -3.05e+11. What is the difference between the Exports (in Local Currency Unit) in Austria in 2005 and the Exports (in Local Currency Unit) in Sweden in 2006?
Provide a short and direct response. -1.37e+12. What is the difference between the Exports (in Local Currency Unit) of Austria in 2005 and the Exports (in Local Currency Unit) of West Bank and Gaza in 2006?
Your answer should be compact. 1.20e+11. What is the difference between the Exports (in Local Currency Unit) of Kenya in 2005 and the Exports (in Local Currency Unit) of Sweden in 2006?
Provide a short and direct response. -1.09e+12. What is the difference between the Exports (in Local Currency Unit) in Kenya in 2005 and the Exports (in Local Currency Unit) in West Bank and Gaza in 2006?
Your response must be concise. 4.00e+11. What is the difference between the Exports (in Local Currency Unit) of Sweden in 2005 and the Exports (in Local Currency Unit) of West Bank and Gaza in 2006?
Offer a terse response. 1.33e+12. What is the difference between the Exports (in Local Currency Unit) of Austria in 2005 and the Exports (in Local Currency Unit) of Kenya in 2007?
Provide a succinct answer. -3.49e+11. What is the difference between the Exports (in Local Currency Unit) in Austria in 2005 and the Exports (in Local Currency Unit) in Sweden in 2007?
Offer a very short reply. -1.47e+12. What is the difference between the Exports (in Local Currency Unit) of Austria in 2005 and the Exports (in Local Currency Unit) of West Bank and Gaza in 2007?
Provide a succinct answer. 1.19e+11. What is the difference between the Exports (in Local Currency Unit) of Kenya in 2005 and the Exports (in Local Currency Unit) of Sweden in 2007?
Your response must be concise. -1.19e+12. What is the difference between the Exports (in Local Currency Unit) of Kenya in 2005 and the Exports (in Local Currency Unit) of West Bank and Gaza in 2007?
Provide a succinct answer. 3.99e+11. What is the difference between the Exports (in Local Currency Unit) in Sweden in 2005 and the Exports (in Local Currency Unit) in West Bank and Gaza in 2007?
Provide a succinct answer. 1.33e+12. What is the difference between the Exports (in Local Currency Unit) in Austria in 2005 and the Exports (in Local Currency Unit) in Kenya in 2008?
Ensure brevity in your answer.  -4.40e+11. What is the difference between the Exports (in Local Currency Unit) of Austria in 2005 and the Exports (in Local Currency Unit) of Sweden in 2008?
Ensure brevity in your answer.  -1.56e+12. What is the difference between the Exports (in Local Currency Unit) of Austria in 2005 and the Exports (in Local Currency Unit) of West Bank and Gaza in 2008?
Your response must be concise. 1.19e+11. What is the difference between the Exports (in Local Currency Unit) in Kenya in 2005 and the Exports (in Local Currency Unit) in Sweden in 2008?
Ensure brevity in your answer.  -1.28e+12. What is the difference between the Exports (in Local Currency Unit) of Kenya in 2005 and the Exports (in Local Currency Unit) of West Bank and Gaza in 2008?
Provide a succinct answer. 3.99e+11. What is the difference between the Exports (in Local Currency Unit) in Sweden in 2005 and the Exports (in Local Currency Unit) in West Bank and Gaza in 2008?
Keep it short and to the point. 1.33e+12. What is the difference between the Exports (in Local Currency Unit) of Austria in 2006 and the Exports (in Local Currency Unit) of Kenya in 2007?
Provide a short and direct response. -3.36e+11. What is the difference between the Exports (in Local Currency Unit) in Austria in 2006 and the Exports (in Local Currency Unit) in Sweden in 2007?
Your response must be concise. -1.46e+12. What is the difference between the Exports (in Local Currency Unit) in Austria in 2006 and the Exports (in Local Currency Unit) in West Bank and Gaza in 2007?
Your answer should be compact. 1.31e+11. What is the difference between the Exports (in Local Currency Unit) in Kenya in 2006 and the Exports (in Local Currency Unit) in Sweden in 2007?
Your answer should be very brief. -1.16e+12. What is the difference between the Exports (in Local Currency Unit) in Kenya in 2006 and the Exports (in Local Currency Unit) in West Bank and Gaza in 2007?
Provide a succinct answer. 4.24e+11. What is the difference between the Exports (in Local Currency Unit) of Sweden in 2006 and the Exports (in Local Currency Unit) of West Bank and Gaza in 2007?
Provide a short and direct response. 1.49e+12. What is the difference between the Exports (in Local Currency Unit) of Austria in 2006 and the Exports (in Local Currency Unit) of Kenya in 2008?
Provide a succinct answer. -4.28e+11. What is the difference between the Exports (in Local Currency Unit) of Austria in 2006 and the Exports (in Local Currency Unit) of Sweden in 2008?
Your answer should be very brief. -1.55e+12. What is the difference between the Exports (in Local Currency Unit) of Austria in 2006 and the Exports (in Local Currency Unit) of West Bank and Gaza in 2008?
Make the answer very short. 1.31e+11. What is the difference between the Exports (in Local Currency Unit) of Kenya in 2006 and the Exports (in Local Currency Unit) of Sweden in 2008?
Ensure brevity in your answer.  -1.26e+12. What is the difference between the Exports (in Local Currency Unit) of Kenya in 2006 and the Exports (in Local Currency Unit) of West Bank and Gaza in 2008?
Offer a very short reply. 4.24e+11. What is the difference between the Exports (in Local Currency Unit) in Sweden in 2006 and the Exports (in Local Currency Unit) in West Bank and Gaza in 2008?
Offer a terse response. 1.49e+12. What is the difference between the Exports (in Local Currency Unit) of Austria in 2007 and the Exports (in Local Currency Unit) of Kenya in 2008?
Ensure brevity in your answer.  -4.15e+11. What is the difference between the Exports (in Local Currency Unit) in Austria in 2007 and the Exports (in Local Currency Unit) in Sweden in 2008?
Give a very brief answer. -1.54e+12. What is the difference between the Exports (in Local Currency Unit) of Austria in 2007 and the Exports (in Local Currency Unit) of West Bank and Gaza in 2008?
Make the answer very short. 1.44e+11. What is the difference between the Exports (in Local Currency Unit) in Kenya in 2007 and the Exports (in Local Currency Unit) in Sweden in 2008?
Offer a very short reply. -1.22e+12. What is the difference between the Exports (in Local Currency Unit) of Kenya in 2007 and the Exports (in Local Currency Unit) of West Bank and Gaza in 2008?
Offer a very short reply. 4.67e+11. What is the difference between the Exports (in Local Currency Unit) in Sweden in 2007 and the Exports (in Local Currency Unit) in West Bank and Gaza in 2008?
Offer a very short reply. 1.59e+12. What is the average Exports (in Local Currency Unit) in Austria per year?
Your answer should be very brief. 1.22e+11. What is the average Exports (in Local Currency Unit) in Kenya per year?
Your response must be concise. 3.71e+11. What is the average Exports (in Local Currency Unit) in Sweden per year?
Make the answer very short. 1.32e+12. What is the average Exports (in Local Currency Unit) in West Bank and Gaza per year?
Give a very brief answer. 3.11e+09. In the year 2001, what is the difference between the Exports (in Local Currency Unit) of Austria and Exports (in Local Currency Unit) of Kenya?
Provide a short and direct response. -1.36e+11. In the year 2001, what is the difference between the Exports (in Local Currency Unit) in Austria and Exports (in Local Currency Unit) in Sweden?
Provide a succinct answer. -9.86e+11. In the year 2001, what is the difference between the Exports (in Local Currency Unit) of Austria and Exports (in Local Currency Unit) of West Bank and Gaza?
Ensure brevity in your answer.  9.58e+1. In the year 2001, what is the difference between the Exports (in Local Currency Unit) in Kenya and Exports (in Local Currency Unit) in Sweden?
Ensure brevity in your answer.  -8.50e+11. In the year 2001, what is the difference between the Exports (in Local Currency Unit) of Kenya and Exports (in Local Currency Unit) of West Bank and Gaza?
Keep it short and to the point. 2.31e+11. In the year 2001, what is the difference between the Exports (in Local Currency Unit) in Sweden and Exports (in Local Currency Unit) in West Bank and Gaza?
Offer a terse response. 1.08e+12. In the year 2002, what is the difference between the Exports (in Local Currency Unit) in Austria and Exports (in Local Currency Unit) in Kenya?
Make the answer very short. -1.55e+11. In the year 2002, what is the difference between the Exports (in Local Currency Unit) of Austria and Exports (in Local Currency Unit) of Sweden?
Your response must be concise. -9.79e+11. In the year 2002, what is the difference between the Exports (in Local Currency Unit) in Austria and Exports (in Local Currency Unit) in West Bank and Gaza?
Your answer should be compact. 1.00e+11. In the year 2002, what is the difference between the Exports (in Local Currency Unit) in Kenya and Exports (in Local Currency Unit) in Sweden?
Your response must be concise. -8.24e+11. In the year 2002, what is the difference between the Exports (in Local Currency Unit) of Kenya and Exports (in Local Currency Unit) of West Bank and Gaza?
Your response must be concise. 2.56e+11. In the year 2002, what is the difference between the Exports (in Local Currency Unit) in Sweden and Exports (in Local Currency Unit) in West Bank and Gaza?
Your answer should be very brief. 1.08e+12. In the year 2003, what is the difference between the Exports (in Local Currency Unit) in Austria and Exports (in Local Currency Unit) in Kenya?
Keep it short and to the point. -1.70e+11. In the year 2003, what is the difference between the Exports (in Local Currency Unit) in Austria and Exports (in Local Currency Unit) in Sweden?
Your answer should be very brief. -1.00e+12. In the year 2003, what is the difference between the Exports (in Local Currency Unit) of Austria and Exports (in Local Currency Unit) of West Bank and Gaza?
Provide a succinct answer. 1.01e+11. In the year 2003, what is the difference between the Exports (in Local Currency Unit) of Kenya and Exports (in Local Currency Unit) of Sweden?
Your answer should be compact. -8.32e+11. In the year 2003, what is the difference between the Exports (in Local Currency Unit) in Kenya and Exports (in Local Currency Unit) in West Bank and Gaza?
Your response must be concise. 2.70e+11. In the year 2003, what is the difference between the Exports (in Local Currency Unit) of Sweden and Exports (in Local Currency Unit) of West Bank and Gaza?
Your answer should be very brief. 1.10e+12. In the year 2004, what is the difference between the Exports (in Local Currency Unit) of Austria and Exports (in Local Currency Unit) of Kenya?
Provide a succinct answer. -2.26e+11. In the year 2004, what is the difference between the Exports (in Local Currency Unit) in Austria and Exports (in Local Currency Unit) in Sweden?
Provide a short and direct response. -1.11e+12. In the year 2004, what is the difference between the Exports (in Local Currency Unit) in Austria and Exports (in Local Currency Unit) in West Bank and Gaza?
Give a very brief answer. 1.11e+11. In the year 2004, what is the difference between the Exports (in Local Currency Unit) in Kenya and Exports (in Local Currency Unit) in Sweden?
Your answer should be compact. -8.80e+11. In the year 2004, what is the difference between the Exports (in Local Currency Unit) of Kenya and Exports (in Local Currency Unit) of West Bank and Gaza?
Your answer should be very brief. 3.36e+11. In the year 2004, what is the difference between the Exports (in Local Currency Unit) in Sweden and Exports (in Local Currency Unit) in West Bank and Gaza?
Your response must be concise. 1.22e+12. In the year 2005, what is the difference between the Exports (in Local Currency Unit) in Austria and Exports (in Local Currency Unit) in Kenya?
Keep it short and to the point. -2.81e+11. In the year 2005, what is the difference between the Exports (in Local Currency Unit) in Austria and Exports (in Local Currency Unit) in Sweden?
Give a very brief answer. -1.21e+12. In the year 2005, what is the difference between the Exports (in Local Currency Unit) in Austria and Exports (in Local Currency Unit) in West Bank and Gaza?
Make the answer very short. 1.20e+11. In the year 2005, what is the difference between the Exports (in Local Currency Unit) of Kenya and Exports (in Local Currency Unit) of Sweden?
Your answer should be compact. -9.30e+11. In the year 2005, what is the difference between the Exports (in Local Currency Unit) of Kenya and Exports (in Local Currency Unit) of West Bank and Gaza?
Make the answer very short. 4.00e+11. In the year 2005, what is the difference between the Exports (in Local Currency Unit) in Sweden and Exports (in Local Currency Unit) in West Bank and Gaza?
Your answer should be compact. 1.33e+12. In the year 2006, what is the difference between the Exports (in Local Currency Unit) of Austria and Exports (in Local Currency Unit) of Kenya?
Offer a terse response. -2.93e+11. In the year 2006, what is the difference between the Exports (in Local Currency Unit) in Austria and Exports (in Local Currency Unit) in Sweden?
Give a very brief answer. -1.36e+12. In the year 2006, what is the difference between the Exports (in Local Currency Unit) of Austria and Exports (in Local Currency Unit) of West Bank and Gaza?
Your response must be concise. 1.32e+11. In the year 2006, what is the difference between the Exports (in Local Currency Unit) in Kenya and Exports (in Local Currency Unit) in Sweden?
Your answer should be compact. -1.07e+12. In the year 2006, what is the difference between the Exports (in Local Currency Unit) of Kenya and Exports (in Local Currency Unit) of West Bank and Gaza?
Your answer should be very brief. 4.25e+11. In the year 2006, what is the difference between the Exports (in Local Currency Unit) in Sweden and Exports (in Local Currency Unit) in West Bank and Gaza?
Provide a succinct answer. 1.49e+12. In the year 2007, what is the difference between the Exports (in Local Currency Unit) in Austria and Exports (in Local Currency Unit) in Kenya?
Provide a short and direct response. -3.23e+11. In the year 2007, what is the difference between the Exports (in Local Currency Unit) in Austria and Exports (in Local Currency Unit) in Sweden?
Provide a succinct answer. -1.44e+12. In the year 2007, what is the difference between the Exports (in Local Currency Unit) in Austria and Exports (in Local Currency Unit) in West Bank and Gaza?
Provide a short and direct response. 1.44e+11. In the year 2007, what is the difference between the Exports (in Local Currency Unit) in Kenya and Exports (in Local Currency Unit) in Sweden?
Offer a terse response. -1.12e+12. In the year 2007, what is the difference between the Exports (in Local Currency Unit) of Kenya and Exports (in Local Currency Unit) of West Bank and Gaza?
Keep it short and to the point. 4.67e+11. In the year 2007, what is the difference between the Exports (in Local Currency Unit) of Sweden and Exports (in Local Currency Unit) of West Bank and Gaza?
Provide a succinct answer. 1.59e+12. In the year 2008, what is the difference between the Exports (in Local Currency Unit) in Austria and Exports (in Local Currency Unit) in Kenya?
Make the answer very short. -4.08e+11. In the year 2008, what is the difference between the Exports (in Local Currency Unit) of Austria and Exports (in Local Currency Unit) of Sweden?
Your answer should be compact. -1.53e+12. In the year 2008, what is the difference between the Exports (in Local Currency Unit) of Austria and Exports (in Local Currency Unit) of West Bank and Gaza?
Provide a succinct answer. 1.51e+11. In the year 2008, what is the difference between the Exports (in Local Currency Unit) in Kenya and Exports (in Local Currency Unit) in Sweden?
Give a very brief answer. -1.12e+12. In the year 2008, what is the difference between the Exports (in Local Currency Unit) of Kenya and Exports (in Local Currency Unit) of West Bank and Gaza?
Your response must be concise. 5.59e+11. In the year 2008, what is the difference between the Exports (in Local Currency Unit) in Sweden and Exports (in Local Currency Unit) in West Bank and Gaza?
Your answer should be very brief. 1.68e+12. What is the ratio of the Exports (in Local Currency Unit) of Austria in 2001 to that in 2002?
Your response must be concise. 0.96. What is the ratio of the Exports (in Local Currency Unit) in Kenya in 2001 to that in 2002?
Keep it short and to the point. 0.91. What is the ratio of the Exports (in Local Currency Unit) in Sweden in 2001 to that in 2002?
Your answer should be compact. 1. What is the ratio of the Exports (in Local Currency Unit) of West Bank and Gaza in 2001 to that in 2002?
Your answer should be compact. 1.14. What is the ratio of the Exports (in Local Currency Unit) of Austria in 2001 to that in 2003?
Your response must be concise. 0.96. What is the ratio of the Exports (in Local Currency Unit) of Kenya in 2001 to that in 2003?
Give a very brief answer. 0.86. What is the ratio of the Exports (in Local Currency Unit) of Sweden in 2001 to that in 2003?
Provide a short and direct response. 0.98. What is the ratio of the Exports (in Local Currency Unit) of West Bank and Gaza in 2001 to that in 2003?
Your answer should be very brief. 1.11. What is the ratio of the Exports (in Local Currency Unit) in Austria in 2001 to that in 2004?
Your answer should be compact. 0.87. What is the ratio of the Exports (in Local Currency Unit) in Kenya in 2001 to that in 2004?
Your response must be concise. 0.69. What is the ratio of the Exports (in Local Currency Unit) of Sweden in 2001 to that in 2004?
Your answer should be very brief. 0.89. What is the ratio of the Exports (in Local Currency Unit) of West Bank and Gaza in 2001 to that in 2004?
Your answer should be very brief. 0.97. What is the ratio of the Exports (in Local Currency Unit) in Austria in 2001 to that in 2005?
Your answer should be very brief. 0.8. What is the ratio of the Exports (in Local Currency Unit) in Kenya in 2001 to that in 2005?
Keep it short and to the point. 0.58. What is the ratio of the Exports (in Local Currency Unit) in Sweden in 2001 to that in 2005?
Provide a succinct answer. 0.81. What is the ratio of the Exports (in Local Currency Unit) of West Bank and Gaza in 2001 to that in 2005?
Your response must be concise. 0.8. What is the ratio of the Exports (in Local Currency Unit) in Austria in 2001 to that in 2006?
Keep it short and to the point. 0.73. What is the ratio of the Exports (in Local Currency Unit) in Kenya in 2001 to that in 2006?
Provide a short and direct response. 0.55. What is the ratio of the Exports (in Local Currency Unit) in Sweden in 2001 to that in 2006?
Offer a very short reply. 0.73. What is the ratio of the Exports (in Local Currency Unit) in West Bank and Gaza in 2001 to that in 2006?
Your answer should be very brief. 0.79. What is the ratio of the Exports (in Local Currency Unit) in Austria in 2001 to that in 2007?
Your answer should be compact. 0.66. What is the ratio of the Exports (in Local Currency Unit) in Kenya in 2001 to that in 2007?
Your answer should be very brief. 0.5. What is the ratio of the Exports (in Local Currency Unit) in Sweden in 2001 to that in 2007?
Provide a short and direct response. 0.68. What is the ratio of the Exports (in Local Currency Unit) in West Bank and Gaza in 2001 to that in 2007?
Give a very brief answer. 0.59. What is the ratio of the Exports (in Local Currency Unit) in Austria in 2001 to that in 2008?
Provide a succinct answer. 0.63. What is the ratio of the Exports (in Local Currency Unit) of Kenya in 2001 to that in 2008?
Offer a very short reply. 0.42. What is the ratio of the Exports (in Local Currency Unit) of Sweden in 2001 to that in 2008?
Provide a succinct answer. 0.64. What is the ratio of the Exports (in Local Currency Unit) of West Bank and Gaza in 2001 to that in 2008?
Offer a terse response. 0.63. What is the ratio of the Exports (in Local Currency Unit) of Austria in 2002 to that in 2003?
Provide a succinct answer. 1. What is the ratio of the Exports (in Local Currency Unit) of Kenya in 2002 to that in 2003?
Provide a short and direct response. 0.95. What is the ratio of the Exports (in Local Currency Unit) of Sweden in 2002 to that in 2003?
Ensure brevity in your answer.  0.98. What is the ratio of the Exports (in Local Currency Unit) of West Bank and Gaza in 2002 to that in 2003?
Provide a short and direct response. 0.97. What is the ratio of the Exports (in Local Currency Unit) in Austria in 2002 to that in 2004?
Your response must be concise. 0.91. What is the ratio of the Exports (in Local Currency Unit) in Kenya in 2002 to that in 2004?
Keep it short and to the point. 0.76. What is the ratio of the Exports (in Local Currency Unit) of Sweden in 2002 to that in 2004?
Your answer should be compact. 0.89. What is the ratio of the Exports (in Local Currency Unit) in West Bank and Gaza in 2002 to that in 2004?
Provide a short and direct response. 0.85. What is the ratio of the Exports (in Local Currency Unit) of Austria in 2002 to that in 2005?
Your answer should be compact. 0.83. What is the ratio of the Exports (in Local Currency Unit) in Kenya in 2002 to that in 2005?
Your response must be concise. 0.64. What is the ratio of the Exports (in Local Currency Unit) in Sweden in 2002 to that in 2005?
Offer a terse response. 0.81. What is the ratio of the Exports (in Local Currency Unit) in West Bank and Gaza in 2002 to that in 2005?
Your answer should be compact. 0.7. What is the ratio of the Exports (in Local Currency Unit) in Austria in 2002 to that in 2006?
Your response must be concise. 0.76. What is the ratio of the Exports (in Local Currency Unit) in Kenya in 2002 to that in 2006?
Provide a succinct answer. 0.6. What is the ratio of the Exports (in Local Currency Unit) of Sweden in 2002 to that in 2006?
Offer a very short reply. 0.72. What is the ratio of the Exports (in Local Currency Unit) in West Bank and Gaza in 2002 to that in 2006?
Provide a short and direct response. 0.69. What is the ratio of the Exports (in Local Currency Unit) in Austria in 2002 to that in 2007?
Give a very brief answer. 0.69. What is the ratio of the Exports (in Local Currency Unit) of Kenya in 2002 to that in 2007?
Offer a very short reply. 0.55. What is the ratio of the Exports (in Local Currency Unit) of Sweden in 2002 to that in 2007?
Offer a terse response. 0.68. What is the ratio of the Exports (in Local Currency Unit) of West Bank and Gaza in 2002 to that in 2007?
Provide a short and direct response. 0.52. What is the ratio of the Exports (in Local Currency Unit) in Austria in 2002 to that in 2008?
Give a very brief answer. 0.66. What is the ratio of the Exports (in Local Currency Unit) in Kenya in 2002 to that in 2008?
Ensure brevity in your answer.  0.46. What is the ratio of the Exports (in Local Currency Unit) in Sweden in 2002 to that in 2008?
Your response must be concise. 0.64. What is the ratio of the Exports (in Local Currency Unit) of West Bank and Gaza in 2002 to that in 2008?
Keep it short and to the point. 0.55. What is the ratio of the Exports (in Local Currency Unit) in Austria in 2003 to that in 2004?
Offer a terse response. 0.91. What is the ratio of the Exports (in Local Currency Unit) in Kenya in 2003 to that in 2004?
Your answer should be very brief. 0.8. What is the ratio of the Exports (in Local Currency Unit) of Sweden in 2003 to that in 2004?
Provide a succinct answer. 0.91. What is the ratio of the Exports (in Local Currency Unit) in West Bank and Gaza in 2003 to that in 2004?
Your answer should be compact. 0.87. What is the ratio of the Exports (in Local Currency Unit) of Austria in 2003 to that in 2005?
Give a very brief answer. 0.84. What is the ratio of the Exports (in Local Currency Unit) of Kenya in 2003 to that in 2005?
Keep it short and to the point. 0.68. What is the ratio of the Exports (in Local Currency Unit) in Sweden in 2003 to that in 2005?
Keep it short and to the point. 0.83. What is the ratio of the Exports (in Local Currency Unit) of West Bank and Gaza in 2003 to that in 2005?
Your answer should be compact. 0.72. What is the ratio of the Exports (in Local Currency Unit) of Austria in 2003 to that in 2006?
Make the answer very short. 0.76. What is the ratio of the Exports (in Local Currency Unit) of Kenya in 2003 to that in 2006?
Your answer should be very brief. 0.64. What is the ratio of the Exports (in Local Currency Unit) in Sweden in 2003 to that in 2006?
Your answer should be compact. 0.74. What is the ratio of the Exports (in Local Currency Unit) of West Bank and Gaza in 2003 to that in 2006?
Ensure brevity in your answer.  0.71. What is the ratio of the Exports (in Local Currency Unit) of Austria in 2003 to that in 2007?
Your response must be concise. 0.69. What is the ratio of the Exports (in Local Currency Unit) of Kenya in 2003 to that in 2007?
Ensure brevity in your answer.  0.58. What is the ratio of the Exports (in Local Currency Unit) of Sweden in 2003 to that in 2007?
Provide a succinct answer. 0.69. What is the ratio of the Exports (in Local Currency Unit) of West Bank and Gaza in 2003 to that in 2007?
Offer a very short reply. 0.53. What is the ratio of the Exports (in Local Currency Unit) of Austria in 2003 to that in 2008?
Your answer should be compact. 0.66. What is the ratio of the Exports (in Local Currency Unit) in Kenya in 2003 to that in 2008?
Provide a short and direct response. 0.48. What is the ratio of the Exports (in Local Currency Unit) of Sweden in 2003 to that in 2008?
Provide a short and direct response. 0.65. What is the ratio of the Exports (in Local Currency Unit) in West Bank and Gaza in 2003 to that in 2008?
Provide a succinct answer. 0.57. What is the ratio of the Exports (in Local Currency Unit) of Austria in 2004 to that in 2005?
Your answer should be compact. 0.92. What is the ratio of the Exports (in Local Currency Unit) of Kenya in 2004 to that in 2005?
Give a very brief answer. 0.84. What is the ratio of the Exports (in Local Currency Unit) in Sweden in 2004 to that in 2005?
Give a very brief answer. 0.91. What is the ratio of the Exports (in Local Currency Unit) in West Bank and Gaza in 2004 to that in 2005?
Provide a succinct answer. 0.82. What is the ratio of the Exports (in Local Currency Unit) in Austria in 2004 to that in 2006?
Ensure brevity in your answer.  0.84. What is the ratio of the Exports (in Local Currency Unit) of Kenya in 2004 to that in 2006?
Make the answer very short. 0.79. What is the ratio of the Exports (in Local Currency Unit) of Sweden in 2004 to that in 2006?
Your answer should be compact. 0.82. What is the ratio of the Exports (in Local Currency Unit) in West Bank and Gaza in 2004 to that in 2006?
Your response must be concise. 0.81. What is the ratio of the Exports (in Local Currency Unit) of Austria in 2004 to that in 2007?
Ensure brevity in your answer.  0.76. What is the ratio of the Exports (in Local Currency Unit) of Kenya in 2004 to that in 2007?
Your answer should be very brief. 0.72. What is the ratio of the Exports (in Local Currency Unit) in Sweden in 2004 to that in 2007?
Offer a terse response. 0.77. What is the ratio of the Exports (in Local Currency Unit) of West Bank and Gaza in 2004 to that in 2007?
Your answer should be compact. 0.61. What is the ratio of the Exports (in Local Currency Unit) of Austria in 2004 to that in 2008?
Give a very brief answer. 0.73. What is the ratio of the Exports (in Local Currency Unit) in Kenya in 2004 to that in 2008?
Provide a short and direct response. 0.6. What is the ratio of the Exports (in Local Currency Unit) of Sweden in 2004 to that in 2008?
Your answer should be compact. 0.72. What is the ratio of the Exports (in Local Currency Unit) in West Bank and Gaza in 2004 to that in 2008?
Offer a very short reply. 0.65. What is the ratio of the Exports (in Local Currency Unit) of Austria in 2005 to that in 2006?
Your response must be concise. 0.91. What is the ratio of the Exports (in Local Currency Unit) in Kenya in 2005 to that in 2006?
Your response must be concise. 0.94. What is the ratio of the Exports (in Local Currency Unit) of Sweden in 2005 to that in 2006?
Ensure brevity in your answer.  0.89. What is the ratio of the Exports (in Local Currency Unit) of Austria in 2005 to that in 2007?
Ensure brevity in your answer.  0.83. What is the ratio of the Exports (in Local Currency Unit) in Kenya in 2005 to that in 2007?
Your answer should be very brief. 0.86. What is the ratio of the Exports (in Local Currency Unit) of Sweden in 2005 to that in 2007?
Keep it short and to the point. 0.84. What is the ratio of the Exports (in Local Currency Unit) in West Bank and Gaza in 2005 to that in 2007?
Ensure brevity in your answer.  0.74. What is the ratio of the Exports (in Local Currency Unit) in Austria in 2005 to that in 2008?
Keep it short and to the point. 0.79. What is the ratio of the Exports (in Local Currency Unit) of Kenya in 2005 to that in 2008?
Make the answer very short. 0.72. What is the ratio of the Exports (in Local Currency Unit) in Sweden in 2005 to that in 2008?
Your response must be concise. 0.79. What is the ratio of the Exports (in Local Currency Unit) in West Bank and Gaza in 2005 to that in 2008?
Provide a short and direct response. 0.79. What is the ratio of the Exports (in Local Currency Unit) in Austria in 2006 to that in 2007?
Make the answer very short. 0.91. What is the ratio of the Exports (in Local Currency Unit) in Kenya in 2006 to that in 2007?
Offer a very short reply. 0.91. What is the ratio of the Exports (in Local Currency Unit) in Sweden in 2006 to that in 2007?
Give a very brief answer. 0.94. What is the ratio of the Exports (in Local Currency Unit) of West Bank and Gaza in 2006 to that in 2007?
Offer a very short reply. 0.75. What is the ratio of the Exports (in Local Currency Unit) in Austria in 2006 to that in 2008?
Your answer should be very brief. 0.87. What is the ratio of the Exports (in Local Currency Unit) of Kenya in 2006 to that in 2008?
Make the answer very short. 0.76. What is the ratio of the Exports (in Local Currency Unit) in Sweden in 2006 to that in 2008?
Your answer should be very brief. 0.89. What is the ratio of the Exports (in Local Currency Unit) of West Bank and Gaza in 2006 to that in 2008?
Offer a terse response. 0.8. What is the ratio of the Exports (in Local Currency Unit) in Austria in 2007 to that in 2008?
Keep it short and to the point. 0.95. What is the ratio of the Exports (in Local Currency Unit) of Kenya in 2007 to that in 2008?
Provide a succinct answer. 0.84. What is the ratio of the Exports (in Local Currency Unit) in Sweden in 2007 to that in 2008?
Your answer should be compact. 0.94. What is the ratio of the Exports (in Local Currency Unit) in West Bank and Gaza in 2007 to that in 2008?
Offer a very short reply. 1.06. What is the difference between the highest and the second highest Exports (in Local Currency Unit) of Austria?
Keep it short and to the point. 6.99e+09. What is the difference between the highest and the second highest Exports (in Local Currency Unit) in Kenya?
Offer a very short reply. 9.15e+1. What is the difference between the highest and the second highest Exports (in Local Currency Unit) of Sweden?
Provide a short and direct response. 9.64e+1. What is the difference between the highest and the second highest Exports (in Local Currency Unit) in West Bank and Gaza?
Your answer should be compact. 2.58e+08. What is the difference between the highest and the lowest Exports (in Local Currency Unit) of Austria?
Your answer should be very brief. 5.68e+1. What is the difference between the highest and the lowest Exports (in Local Currency Unit) of Kenya?
Offer a terse response. 3.29e+11. What is the difference between the highest and the lowest Exports (in Local Currency Unit) in Sweden?
Ensure brevity in your answer.  6.06e+11. What is the difference between the highest and the lowest Exports (in Local Currency Unit) in West Bank and Gaza?
Offer a terse response. 2.12e+09. 